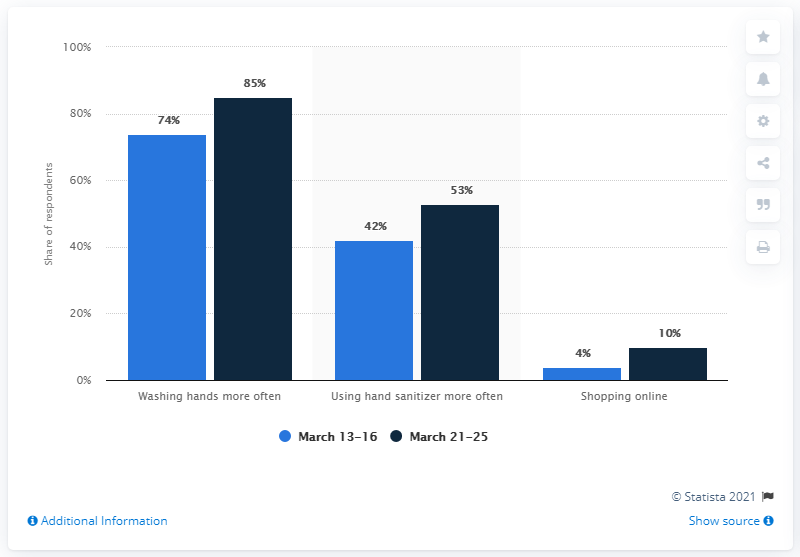Specify some key components in this picture. The lowest value in the dark blue bar is 10. After the COVID-19 outbreak, 85% of Swedes reported washing their hands more frequently one week later. In the United States, approximately 14% of all shopping is done online. 